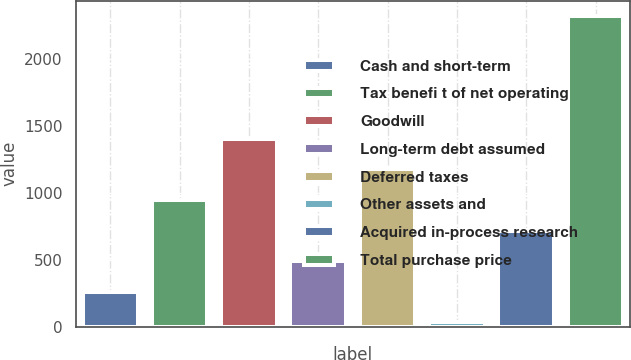Convert chart. <chart><loc_0><loc_0><loc_500><loc_500><bar_chart><fcel>Cash and short-term<fcel>Tax benefi t of net operating<fcel>Goodwill<fcel>Long-term debt assumed<fcel>Deferred taxes<fcel>Other assets and<fcel>Acquired in-process research<fcel>Total purchase price<nl><fcel>260.96<fcel>947.54<fcel>1405.26<fcel>489.82<fcel>1176.4<fcel>32.1<fcel>718.68<fcel>2320.7<nl></chart> 